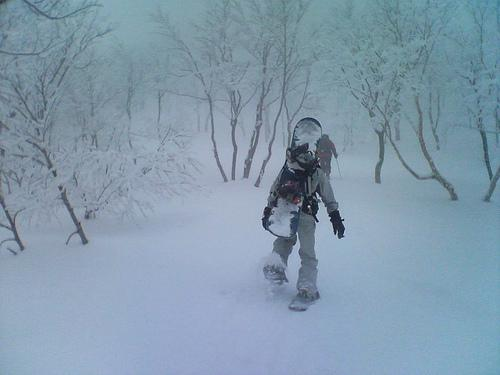Question: who is in the forest?
Choices:
A. Women.
B. Animals.
C. No one.
D. Men.
Answer with the letter. Answer: D Question: why it is snowing?
Choices:
A. It's winter.
B. It is dry.
C. It's summer.
D. It's hot.
Answer with the letter. Answer: A Question: when did it snowed?
Choices:
A. Now.
B. A few days ago.
C. A few months ago.
D. Never.
Answer with the letter. Answer: A 